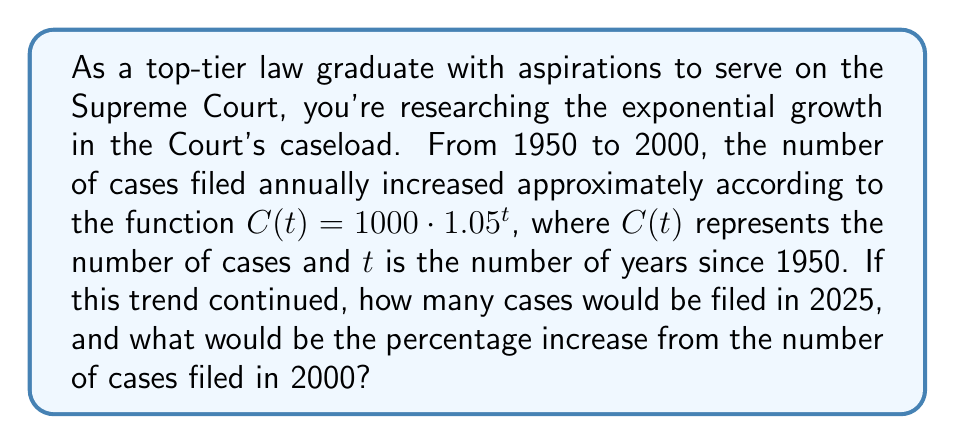Give your solution to this math problem. To solve this problem, we need to follow these steps:

1. Calculate the number of cases in 2000 (t = 50):
   $$C(50) = 1000 \cdot 1.05^{50} = 1000 \cdot 11.4674 = 11,467$$

2. Calculate the number of cases in 2025 (t = 75):
   $$C(75) = 1000 \cdot 1.05^{75} = 1000 \cdot 37.1528 = 37,153$$

3. Calculate the percentage increase:
   Percentage increase = $\frac{\text{Increase}}{\text{Original}} \times 100\%$
   $$= \frac{37,153 - 11,467}{11,467} \times 100\%$$
   $$= \frac{25,686}{11,467} \times 100\% = 224.0\%$$

Therefore, if the trend continued, there would be 37,153 cases filed in 2025, representing a 224.0% increase from 2000.
Answer: 37,153 cases in 2025; 224.0% increase from 2000 